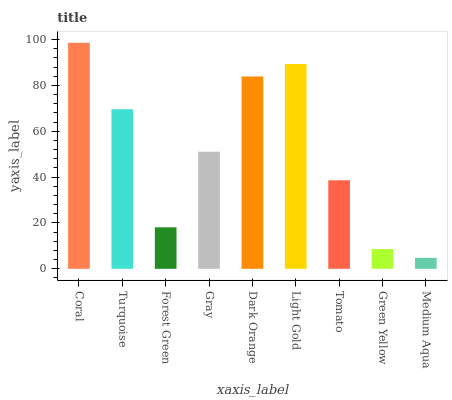Is Medium Aqua the minimum?
Answer yes or no. Yes. Is Coral the maximum?
Answer yes or no. Yes. Is Turquoise the minimum?
Answer yes or no. No. Is Turquoise the maximum?
Answer yes or no. No. Is Coral greater than Turquoise?
Answer yes or no. Yes. Is Turquoise less than Coral?
Answer yes or no. Yes. Is Turquoise greater than Coral?
Answer yes or no. No. Is Coral less than Turquoise?
Answer yes or no. No. Is Gray the high median?
Answer yes or no. Yes. Is Gray the low median?
Answer yes or no. Yes. Is Tomato the high median?
Answer yes or no. No. Is Green Yellow the low median?
Answer yes or no. No. 